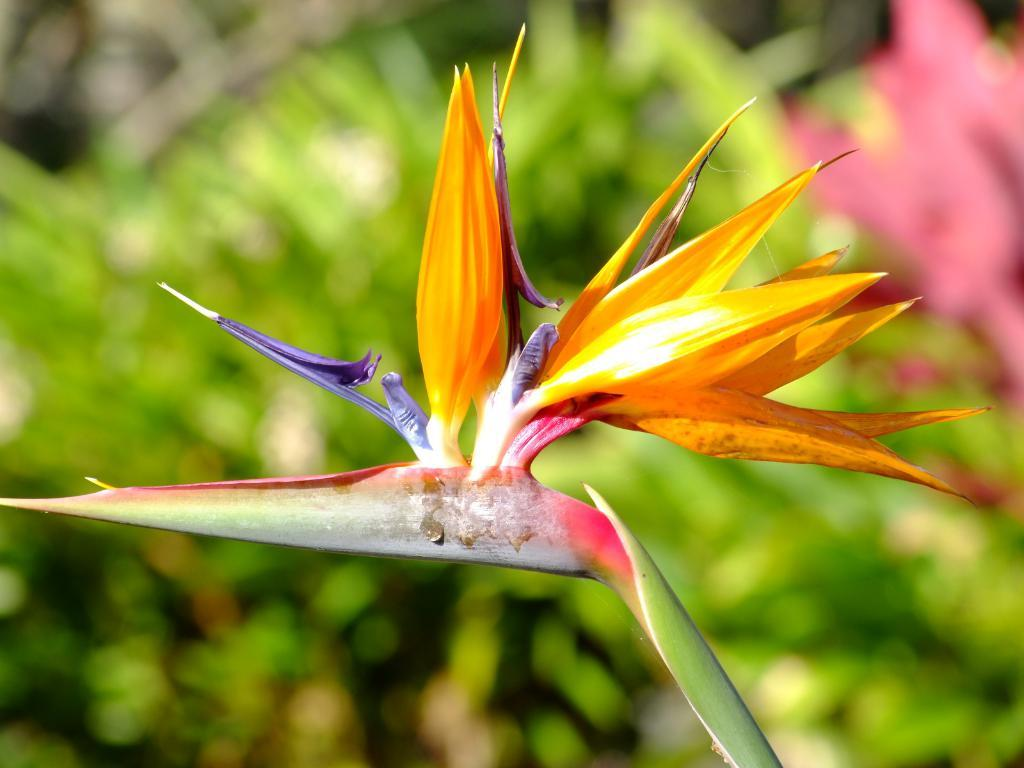What is the main subject of the image? There is a flower on a plant in the image. Can you describe the plant that the flower is on? The plant is not described in detail, but it is the one that the flower is on. What else can be seen in the background of the image? There are other plants visible in the background of the image. What type of sand can be seen on the pizzas in the image? There are no pizzas or sand present in the image; it features a flower on a plant and other plants in the background. 